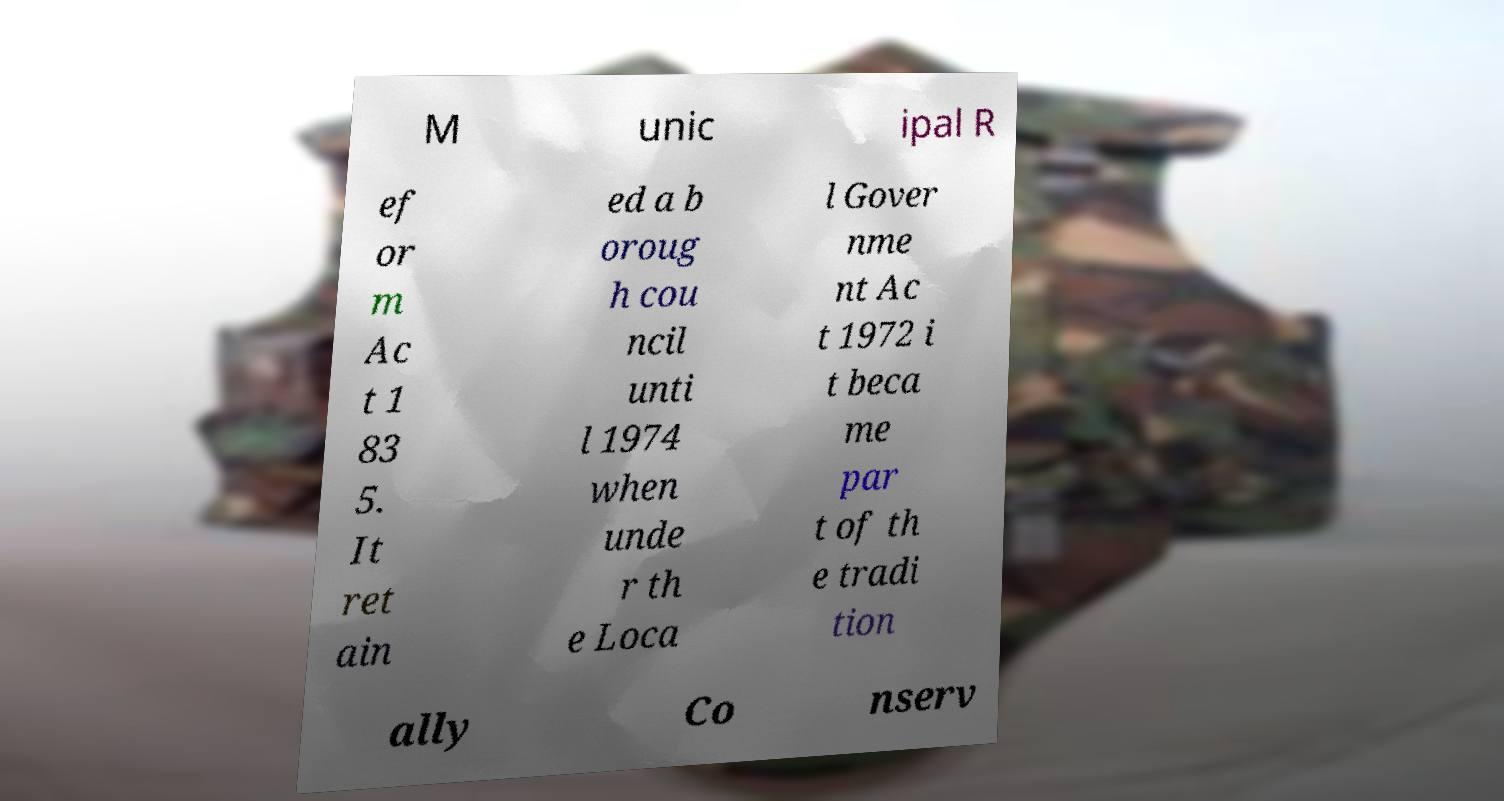Can you read and provide the text displayed in the image?This photo seems to have some interesting text. Can you extract and type it out for me? M unic ipal R ef or m Ac t 1 83 5. It ret ain ed a b oroug h cou ncil unti l 1974 when unde r th e Loca l Gover nme nt Ac t 1972 i t beca me par t of th e tradi tion ally Co nserv 